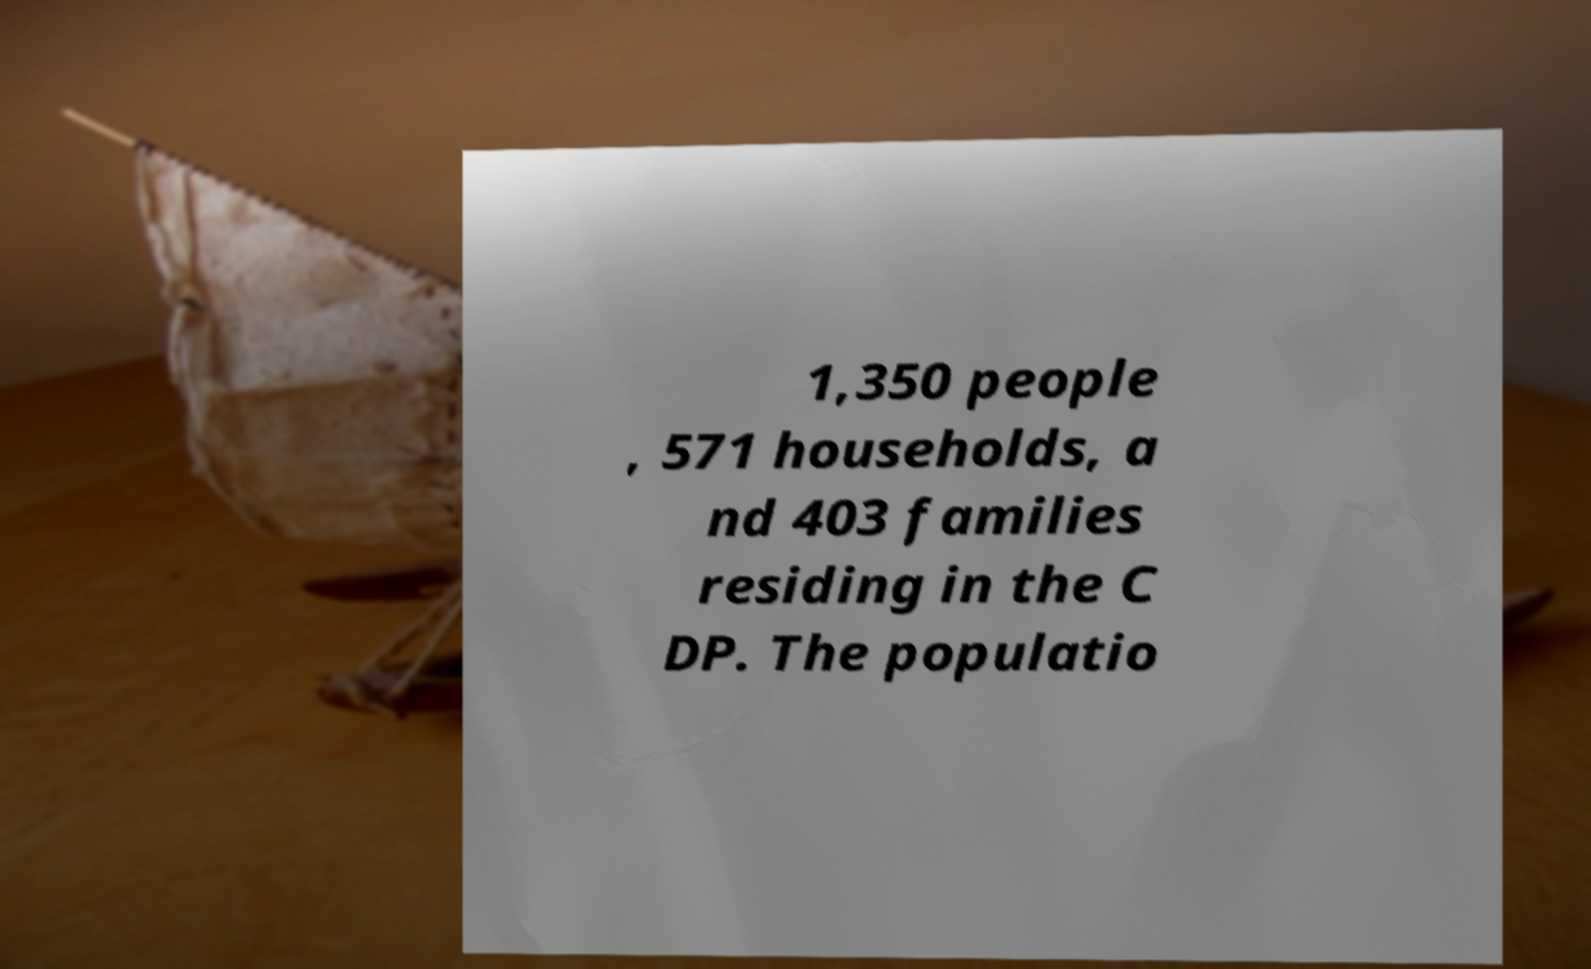Please read and relay the text visible in this image. What does it say? 1,350 people , 571 households, a nd 403 families residing in the C DP. The populatio 